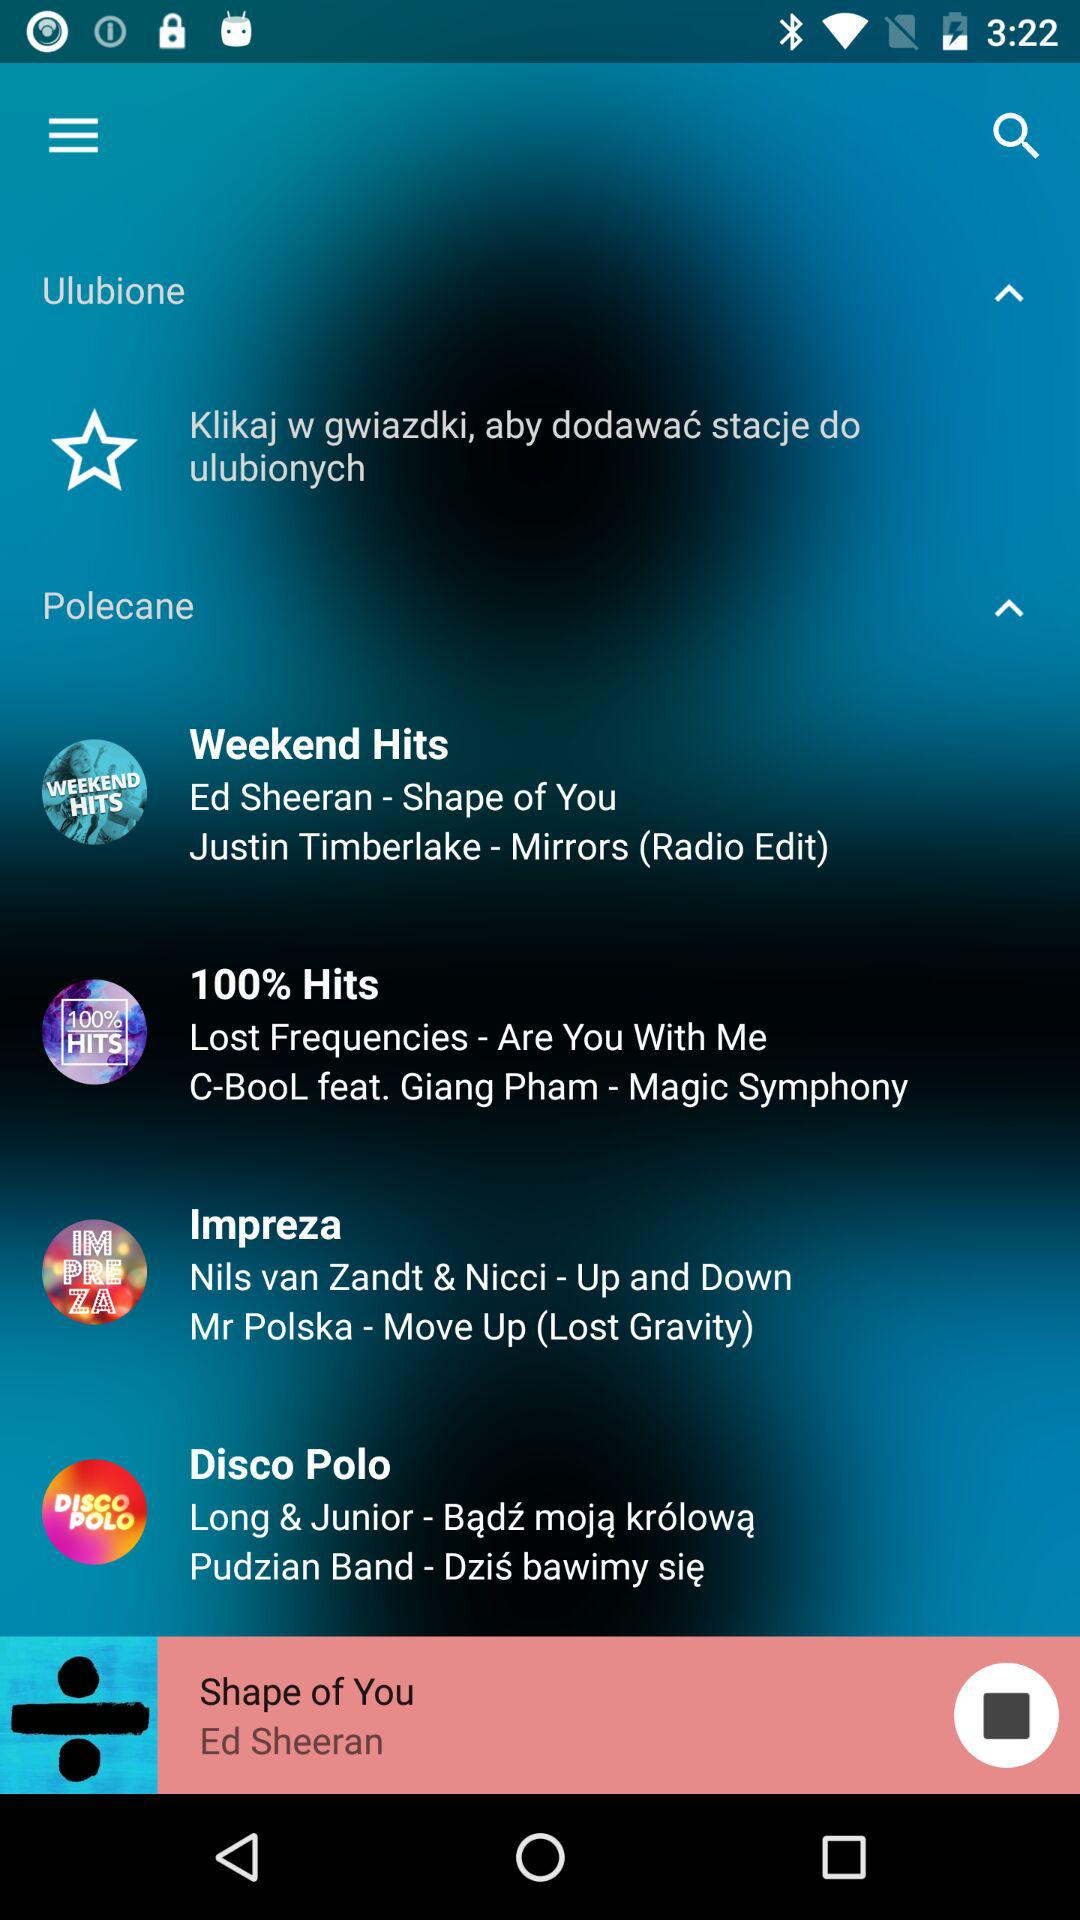Who is the singer of the song "Shape of You"? The singer is Ed Sheeran. 